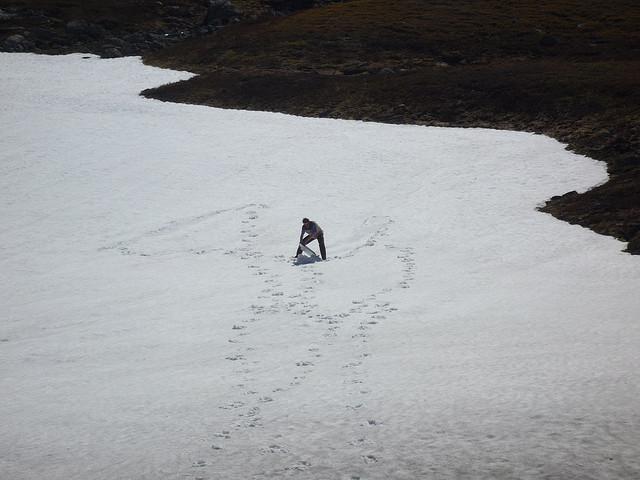How many people are in the picture?
Give a very brief answer. 1. How many zebras are facing the right?
Give a very brief answer. 0. 